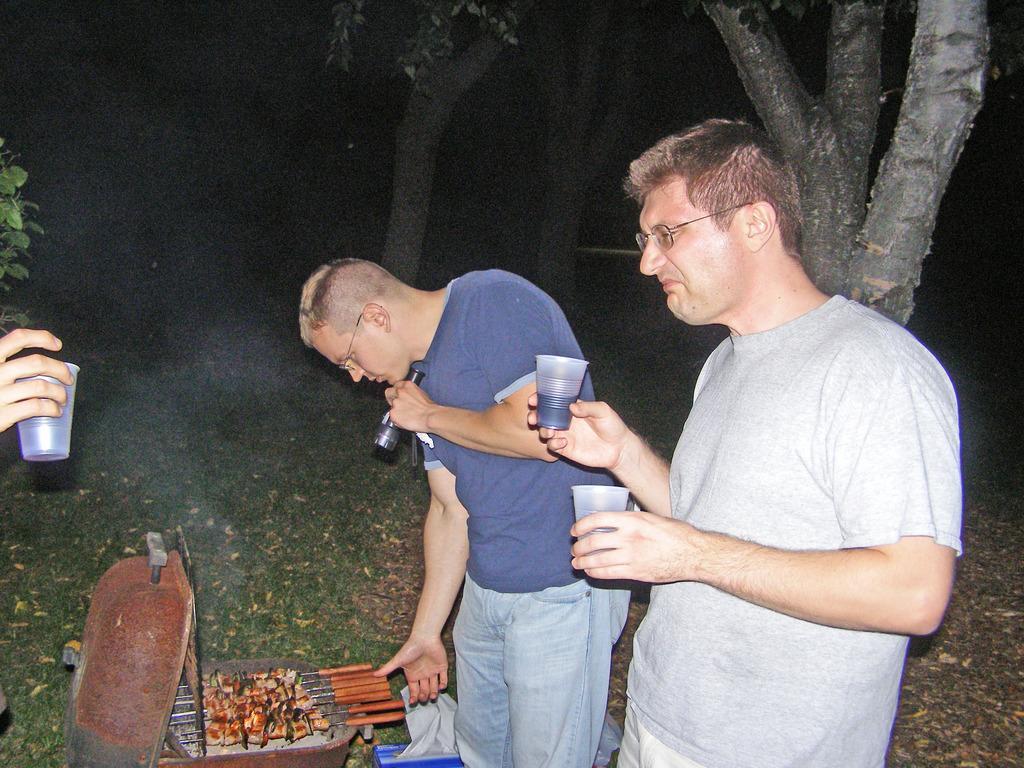Could you give a brief overview of what you see in this image? Here men are standing holding glass, these are food items in the container, these are trees. 